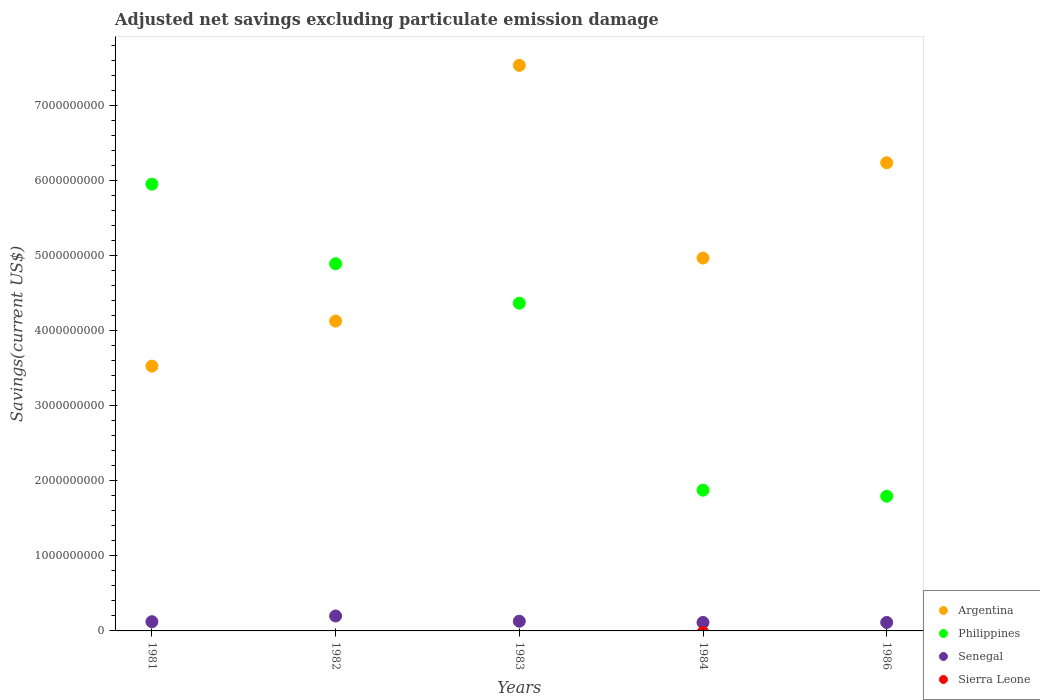How many different coloured dotlines are there?
Provide a succinct answer. 3. What is the adjusted net savings in Philippines in 1984?
Your answer should be very brief. 1.88e+09. Across all years, what is the maximum adjusted net savings in Senegal?
Your answer should be compact. 1.99e+08. Across all years, what is the minimum adjusted net savings in Senegal?
Your response must be concise. 1.13e+08. In which year was the adjusted net savings in Argentina maximum?
Your answer should be very brief. 1983. What is the total adjusted net savings in Philippines in the graph?
Provide a succinct answer. 1.89e+1. What is the difference between the adjusted net savings in Philippines in 1981 and that in 1984?
Make the answer very short. 4.08e+09. What is the difference between the adjusted net savings in Senegal in 1986 and the adjusted net savings in Sierra Leone in 1982?
Your answer should be compact. 1.13e+08. What is the average adjusted net savings in Philippines per year?
Make the answer very short. 3.78e+09. In the year 1982, what is the difference between the adjusted net savings in Senegal and adjusted net savings in Philippines?
Keep it short and to the point. -4.69e+09. In how many years, is the adjusted net savings in Argentina greater than 2800000000 US$?
Provide a short and direct response. 5. What is the ratio of the adjusted net savings in Philippines in 1981 to that in 1986?
Ensure brevity in your answer.  3.32. Is the adjusted net savings in Philippines in 1982 less than that in 1986?
Make the answer very short. No. Is the difference between the adjusted net savings in Senegal in 1981 and 1982 greater than the difference between the adjusted net savings in Philippines in 1981 and 1982?
Your response must be concise. No. What is the difference between the highest and the second highest adjusted net savings in Argentina?
Ensure brevity in your answer.  1.30e+09. What is the difference between the highest and the lowest adjusted net savings in Argentina?
Ensure brevity in your answer.  4.01e+09. In how many years, is the adjusted net savings in Philippines greater than the average adjusted net savings in Philippines taken over all years?
Keep it short and to the point. 3. Is the sum of the adjusted net savings in Senegal in 1981 and 1984 greater than the maximum adjusted net savings in Philippines across all years?
Keep it short and to the point. No. Is it the case that in every year, the sum of the adjusted net savings in Argentina and adjusted net savings in Philippines  is greater than the sum of adjusted net savings in Sierra Leone and adjusted net savings in Senegal?
Offer a very short reply. No. Is it the case that in every year, the sum of the adjusted net savings in Sierra Leone and adjusted net savings in Senegal  is greater than the adjusted net savings in Philippines?
Your answer should be compact. No. Does the adjusted net savings in Sierra Leone monotonically increase over the years?
Provide a succinct answer. No. Is the adjusted net savings in Senegal strictly greater than the adjusted net savings in Sierra Leone over the years?
Offer a very short reply. Yes. Is the adjusted net savings in Sierra Leone strictly less than the adjusted net savings in Philippines over the years?
Provide a short and direct response. Yes. How many dotlines are there?
Your answer should be very brief. 3. How many years are there in the graph?
Your response must be concise. 5. What is the difference between two consecutive major ticks on the Y-axis?
Provide a succinct answer. 1.00e+09. Are the values on the major ticks of Y-axis written in scientific E-notation?
Provide a succinct answer. No. Does the graph contain any zero values?
Provide a succinct answer. Yes. Does the graph contain grids?
Your answer should be very brief. No. How many legend labels are there?
Keep it short and to the point. 4. How are the legend labels stacked?
Provide a succinct answer. Vertical. What is the title of the graph?
Provide a succinct answer. Adjusted net savings excluding particulate emission damage. What is the label or title of the Y-axis?
Provide a succinct answer. Savings(current US$). What is the Savings(current US$) of Argentina in 1981?
Your answer should be compact. 3.53e+09. What is the Savings(current US$) of Philippines in 1981?
Offer a very short reply. 5.95e+09. What is the Savings(current US$) in Senegal in 1981?
Offer a very short reply. 1.23e+08. What is the Savings(current US$) of Argentina in 1982?
Provide a succinct answer. 4.13e+09. What is the Savings(current US$) of Philippines in 1982?
Offer a very short reply. 4.89e+09. What is the Savings(current US$) of Senegal in 1982?
Offer a terse response. 1.99e+08. What is the Savings(current US$) of Argentina in 1983?
Ensure brevity in your answer.  7.54e+09. What is the Savings(current US$) in Philippines in 1983?
Ensure brevity in your answer.  4.37e+09. What is the Savings(current US$) in Senegal in 1983?
Your answer should be very brief. 1.29e+08. What is the Savings(current US$) in Argentina in 1984?
Offer a terse response. 4.97e+09. What is the Savings(current US$) in Philippines in 1984?
Ensure brevity in your answer.  1.88e+09. What is the Savings(current US$) in Senegal in 1984?
Provide a succinct answer. 1.13e+08. What is the Savings(current US$) in Argentina in 1986?
Your answer should be compact. 6.24e+09. What is the Savings(current US$) of Philippines in 1986?
Your response must be concise. 1.80e+09. What is the Savings(current US$) in Senegal in 1986?
Offer a terse response. 1.13e+08. What is the Savings(current US$) of Sierra Leone in 1986?
Make the answer very short. 0. Across all years, what is the maximum Savings(current US$) of Argentina?
Keep it short and to the point. 7.54e+09. Across all years, what is the maximum Savings(current US$) of Philippines?
Give a very brief answer. 5.95e+09. Across all years, what is the maximum Savings(current US$) in Senegal?
Keep it short and to the point. 1.99e+08. Across all years, what is the minimum Savings(current US$) of Argentina?
Provide a short and direct response. 3.53e+09. Across all years, what is the minimum Savings(current US$) in Philippines?
Ensure brevity in your answer.  1.80e+09. Across all years, what is the minimum Savings(current US$) of Senegal?
Make the answer very short. 1.13e+08. What is the total Savings(current US$) in Argentina in the graph?
Keep it short and to the point. 2.64e+1. What is the total Savings(current US$) of Philippines in the graph?
Your answer should be very brief. 1.89e+1. What is the total Savings(current US$) in Senegal in the graph?
Offer a terse response. 6.77e+08. What is the total Savings(current US$) in Sierra Leone in the graph?
Offer a very short reply. 0. What is the difference between the Savings(current US$) in Argentina in 1981 and that in 1982?
Give a very brief answer. -6.01e+08. What is the difference between the Savings(current US$) in Philippines in 1981 and that in 1982?
Offer a very short reply. 1.06e+09. What is the difference between the Savings(current US$) of Senegal in 1981 and that in 1982?
Provide a succinct answer. -7.59e+07. What is the difference between the Savings(current US$) of Argentina in 1981 and that in 1983?
Your response must be concise. -4.01e+09. What is the difference between the Savings(current US$) in Philippines in 1981 and that in 1983?
Your response must be concise. 1.59e+09. What is the difference between the Savings(current US$) in Senegal in 1981 and that in 1983?
Provide a short and direct response. -6.29e+06. What is the difference between the Savings(current US$) of Argentina in 1981 and that in 1984?
Provide a short and direct response. -1.44e+09. What is the difference between the Savings(current US$) in Philippines in 1981 and that in 1984?
Ensure brevity in your answer.  4.08e+09. What is the difference between the Savings(current US$) in Senegal in 1981 and that in 1984?
Make the answer very short. 1.05e+07. What is the difference between the Savings(current US$) in Argentina in 1981 and that in 1986?
Keep it short and to the point. -2.71e+09. What is the difference between the Savings(current US$) of Philippines in 1981 and that in 1986?
Ensure brevity in your answer.  4.16e+09. What is the difference between the Savings(current US$) in Senegal in 1981 and that in 1986?
Provide a succinct answer. 9.89e+06. What is the difference between the Savings(current US$) of Argentina in 1982 and that in 1983?
Keep it short and to the point. -3.41e+09. What is the difference between the Savings(current US$) in Philippines in 1982 and that in 1983?
Your response must be concise. 5.26e+08. What is the difference between the Savings(current US$) in Senegal in 1982 and that in 1983?
Your response must be concise. 6.96e+07. What is the difference between the Savings(current US$) of Argentina in 1982 and that in 1984?
Your answer should be compact. -8.40e+08. What is the difference between the Savings(current US$) in Philippines in 1982 and that in 1984?
Your answer should be compact. 3.02e+09. What is the difference between the Savings(current US$) of Senegal in 1982 and that in 1984?
Keep it short and to the point. 8.64e+07. What is the difference between the Savings(current US$) of Argentina in 1982 and that in 1986?
Ensure brevity in your answer.  -2.11e+09. What is the difference between the Savings(current US$) of Philippines in 1982 and that in 1986?
Ensure brevity in your answer.  3.10e+09. What is the difference between the Savings(current US$) of Senegal in 1982 and that in 1986?
Your response must be concise. 8.58e+07. What is the difference between the Savings(current US$) of Argentina in 1983 and that in 1984?
Give a very brief answer. 2.57e+09. What is the difference between the Savings(current US$) in Philippines in 1983 and that in 1984?
Ensure brevity in your answer.  2.49e+09. What is the difference between the Savings(current US$) in Senegal in 1983 and that in 1984?
Your answer should be very brief. 1.68e+07. What is the difference between the Savings(current US$) in Argentina in 1983 and that in 1986?
Make the answer very short. 1.30e+09. What is the difference between the Savings(current US$) in Philippines in 1983 and that in 1986?
Provide a short and direct response. 2.57e+09. What is the difference between the Savings(current US$) of Senegal in 1983 and that in 1986?
Keep it short and to the point. 1.62e+07. What is the difference between the Savings(current US$) of Argentina in 1984 and that in 1986?
Your answer should be very brief. -1.27e+09. What is the difference between the Savings(current US$) in Philippines in 1984 and that in 1986?
Your answer should be compact. 8.08e+07. What is the difference between the Savings(current US$) in Senegal in 1984 and that in 1986?
Make the answer very short. -5.72e+05. What is the difference between the Savings(current US$) of Argentina in 1981 and the Savings(current US$) of Philippines in 1982?
Provide a short and direct response. -1.36e+09. What is the difference between the Savings(current US$) of Argentina in 1981 and the Savings(current US$) of Senegal in 1982?
Provide a succinct answer. 3.33e+09. What is the difference between the Savings(current US$) of Philippines in 1981 and the Savings(current US$) of Senegal in 1982?
Provide a short and direct response. 5.75e+09. What is the difference between the Savings(current US$) of Argentina in 1981 and the Savings(current US$) of Philippines in 1983?
Your answer should be very brief. -8.39e+08. What is the difference between the Savings(current US$) in Argentina in 1981 and the Savings(current US$) in Senegal in 1983?
Offer a very short reply. 3.40e+09. What is the difference between the Savings(current US$) of Philippines in 1981 and the Savings(current US$) of Senegal in 1983?
Your answer should be compact. 5.82e+09. What is the difference between the Savings(current US$) of Argentina in 1981 and the Savings(current US$) of Philippines in 1984?
Keep it short and to the point. 1.65e+09. What is the difference between the Savings(current US$) of Argentina in 1981 and the Savings(current US$) of Senegal in 1984?
Your answer should be very brief. 3.42e+09. What is the difference between the Savings(current US$) in Philippines in 1981 and the Savings(current US$) in Senegal in 1984?
Ensure brevity in your answer.  5.84e+09. What is the difference between the Savings(current US$) in Argentina in 1981 and the Savings(current US$) in Philippines in 1986?
Your response must be concise. 1.73e+09. What is the difference between the Savings(current US$) in Argentina in 1981 and the Savings(current US$) in Senegal in 1986?
Offer a very short reply. 3.42e+09. What is the difference between the Savings(current US$) in Philippines in 1981 and the Savings(current US$) in Senegal in 1986?
Provide a short and direct response. 5.84e+09. What is the difference between the Savings(current US$) of Argentina in 1982 and the Savings(current US$) of Philippines in 1983?
Offer a terse response. -2.38e+08. What is the difference between the Savings(current US$) of Argentina in 1982 and the Savings(current US$) of Senegal in 1983?
Give a very brief answer. 4.00e+09. What is the difference between the Savings(current US$) of Philippines in 1982 and the Savings(current US$) of Senegal in 1983?
Provide a short and direct response. 4.76e+09. What is the difference between the Savings(current US$) of Argentina in 1982 and the Savings(current US$) of Philippines in 1984?
Provide a short and direct response. 2.25e+09. What is the difference between the Savings(current US$) of Argentina in 1982 and the Savings(current US$) of Senegal in 1984?
Offer a terse response. 4.02e+09. What is the difference between the Savings(current US$) of Philippines in 1982 and the Savings(current US$) of Senegal in 1984?
Provide a succinct answer. 4.78e+09. What is the difference between the Savings(current US$) in Argentina in 1982 and the Savings(current US$) in Philippines in 1986?
Make the answer very short. 2.33e+09. What is the difference between the Savings(current US$) of Argentina in 1982 and the Savings(current US$) of Senegal in 1986?
Make the answer very short. 4.02e+09. What is the difference between the Savings(current US$) of Philippines in 1982 and the Savings(current US$) of Senegal in 1986?
Give a very brief answer. 4.78e+09. What is the difference between the Savings(current US$) in Argentina in 1983 and the Savings(current US$) in Philippines in 1984?
Ensure brevity in your answer.  5.66e+09. What is the difference between the Savings(current US$) in Argentina in 1983 and the Savings(current US$) in Senegal in 1984?
Make the answer very short. 7.42e+09. What is the difference between the Savings(current US$) in Philippines in 1983 and the Savings(current US$) in Senegal in 1984?
Your response must be concise. 4.25e+09. What is the difference between the Savings(current US$) of Argentina in 1983 and the Savings(current US$) of Philippines in 1986?
Your answer should be compact. 5.74e+09. What is the difference between the Savings(current US$) in Argentina in 1983 and the Savings(current US$) in Senegal in 1986?
Provide a short and direct response. 7.42e+09. What is the difference between the Savings(current US$) of Philippines in 1983 and the Savings(current US$) of Senegal in 1986?
Keep it short and to the point. 4.25e+09. What is the difference between the Savings(current US$) in Argentina in 1984 and the Savings(current US$) in Philippines in 1986?
Keep it short and to the point. 3.17e+09. What is the difference between the Savings(current US$) of Argentina in 1984 and the Savings(current US$) of Senegal in 1986?
Give a very brief answer. 4.86e+09. What is the difference between the Savings(current US$) in Philippines in 1984 and the Savings(current US$) in Senegal in 1986?
Ensure brevity in your answer.  1.76e+09. What is the average Savings(current US$) of Argentina per year?
Provide a succinct answer. 5.28e+09. What is the average Savings(current US$) in Philippines per year?
Keep it short and to the point. 3.78e+09. What is the average Savings(current US$) of Senegal per year?
Your answer should be very brief. 1.35e+08. What is the average Savings(current US$) of Sierra Leone per year?
Keep it short and to the point. 0. In the year 1981, what is the difference between the Savings(current US$) of Argentina and Savings(current US$) of Philippines?
Provide a succinct answer. -2.43e+09. In the year 1981, what is the difference between the Savings(current US$) in Argentina and Savings(current US$) in Senegal?
Ensure brevity in your answer.  3.41e+09. In the year 1981, what is the difference between the Savings(current US$) in Philippines and Savings(current US$) in Senegal?
Give a very brief answer. 5.83e+09. In the year 1982, what is the difference between the Savings(current US$) in Argentina and Savings(current US$) in Philippines?
Make the answer very short. -7.64e+08. In the year 1982, what is the difference between the Savings(current US$) in Argentina and Savings(current US$) in Senegal?
Provide a succinct answer. 3.93e+09. In the year 1982, what is the difference between the Savings(current US$) of Philippines and Savings(current US$) of Senegal?
Ensure brevity in your answer.  4.69e+09. In the year 1983, what is the difference between the Savings(current US$) of Argentina and Savings(current US$) of Philippines?
Give a very brief answer. 3.17e+09. In the year 1983, what is the difference between the Savings(current US$) in Argentina and Savings(current US$) in Senegal?
Provide a short and direct response. 7.41e+09. In the year 1983, what is the difference between the Savings(current US$) of Philippines and Savings(current US$) of Senegal?
Offer a terse response. 4.24e+09. In the year 1984, what is the difference between the Savings(current US$) in Argentina and Savings(current US$) in Philippines?
Your answer should be compact. 3.09e+09. In the year 1984, what is the difference between the Savings(current US$) in Argentina and Savings(current US$) in Senegal?
Keep it short and to the point. 4.86e+09. In the year 1984, what is the difference between the Savings(current US$) of Philippines and Savings(current US$) of Senegal?
Ensure brevity in your answer.  1.76e+09. In the year 1986, what is the difference between the Savings(current US$) of Argentina and Savings(current US$) of Philippines?
Ensure brevity in your answer.  4.44e+09. In the year 1986, what is the difference between the Savings(current US$) in Argentina and Savings(current US$) in Senegal?
Offer a terse response. 6.13e+09. In the year 1986, what is the difference between the Savings(current US$) in Philippines and Savings(current US$) in Senegal?
Ensure brevity in your answer.  1.68e+09. What is the ratio of the Savings(current US$) of Argentina in 1981 to that in 1982?
Your answer should be compact. 0.85. What is the ratio of the Savings(current US$) of Philippines in 1981 to that in 1982?
Make the answer very short. 1.22. What is the ratio of the Savings(current US$) of Senegal in 1981 to that in 1982?
Your response must be concise. 0.62. What is the ratio of the Savings(current US$) of Argentina in 1981 to that in 1983?
Offer a terse response. 0.47. What is the ratio of the Savings(current US$) of Philippines in 1981 to that in 1983?
Your answer should be compact. 1.36. What is the ratio of the Savings(current US$) in Senegal in 1981 to that in 1983?
Offer a very short reply. 0.95. What is the ratio of the Savings(current US$) in Argentina in 1981 to that in 1984?
Offer a terse response. 0.71. What is the ratio of the Savings(current US$) of Philippines in 1981 to that in 1984?
Offer a very short reply. 3.17. What is the ratio of the Savings(current US$) in Senegal in 1981 to that in 1984?
Offer a very short reply. 1.09. What is the ratio of the Savings(current US$) of Argentina in 1981 to that in 1986?
Keep it short and to the point. 0.57. What is the ratio of the Savings(current US$) of Philippines in 1981 to that in 1986?
Your answer should be very brief. 3.32. What is the ratio of the Savings(current US$) of Senegal in 1981 to that in 1986?
Your response must be concise. 1.09. What is the ratio of the Savings(current US$) of Argentina in 1982 to that in 1983?
Ensure brevity in your answer.  0.55. What is the ratio of the Savings(current US$) in Philippines in 1982 to that in 1983?
Ensure brevity in your answer.  1.12. What is the ratio of the Savings(current US$) in Senegal in 1982 to that in 1983?
Make the answer very short. 1.54. What is the ratio of the Savings(current US$) in Argentina in 1982 to that in 1984?
Offer a very short reply. 0.83. What is the ratio of the Savings(current US$) of Philippines in 1982 to that in 1984?
Offer a terse response. 2.61. What is the ratio of the Savings(current US$) in Senegal in 1982 to that in 1984?
Make the answer very short. 1.77. What is the ratio of the Savings(current US$) of Argentina in 1982 to that in 1986?
Give a very brief answer. 0.66. What is the ratio of the Savings(current US$) of Philippines in 1982 to that in 1986?
Offer a terse response. 2.73. What is the ratio of the Savings(current US$) in Senegal in 1982 to that in 1986?
Ensure brevity in your answer.  1.76. What is the ratio of the Savings(current US$) in Argentina in 1983 to that in 1984?
Give a very brief answer. 1.52. What is the ratio of the Savings(current US$) in Philippines in 1983 to that in 1984?
Ensure brevity in your answer.  2.33. What is the ratio of the Savings(current US$) in Senegal in 1983 to that in 1984?
Give a very brief answer. 1.15. What is the ratio of the Savings(current US$) of Argentina in 1983 to that in 1986?
Provide a short and direct response. 1.21. What is the ratio of the Savings(current US$) of Philippines in 1983 to that in 1986?
Give a very brief answer. 2.43. What is the ratio of the Savings(current US$) of Senegal in 1983 to that in 1986?
Your answer should be compact. 1.14. What is the ratio of the Savings(current US$) of Argentina in 1984 to that in 1986?
Your answer should be compact. 0.8. What is the ratio of the Savings(current US$) in Philippines in 1984 to that in 1986?
Provide a short and direct response. 1.04. What is the difference between the highest and the second highest Savings(current US$) in Argentina?
Your answer should be compact. 1.30e+09. What is the difference between the highest and the second highest Savings(current US$) of Philippines?
Offer a terse response. 1.06e+09. What is the difference between the highest and the second highest Savings(current US$) of Senegal?
Provide a short and direct response. 6.96e+07. What is the difference between the highest and the lowest Savings(current US$) of Argentina?
Make the answer very short. 4.01e+09. What is the difference between the highest and the lowest Savings(current US$) in Philippines?
Make the answer very short. 4.16e+09. What is the difference between the highest and the lowest Savings(current US$) in Senegal?
Provide a succinct answer. 8.64e+07. 